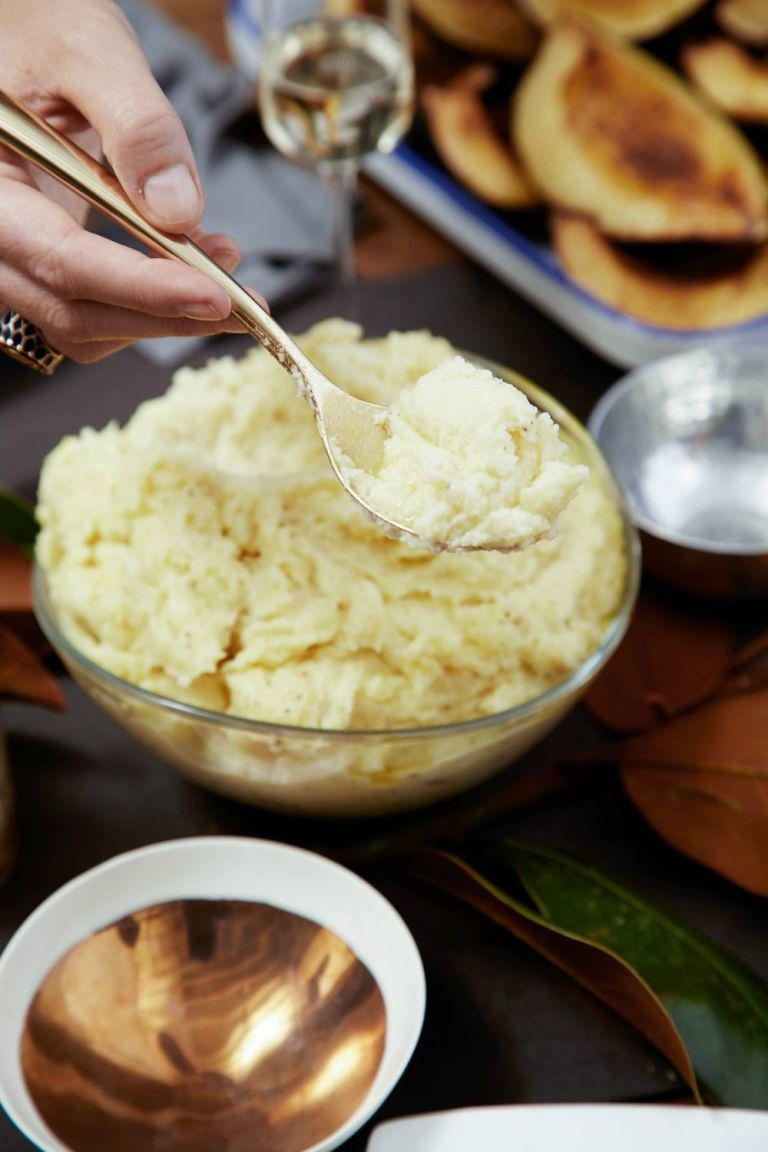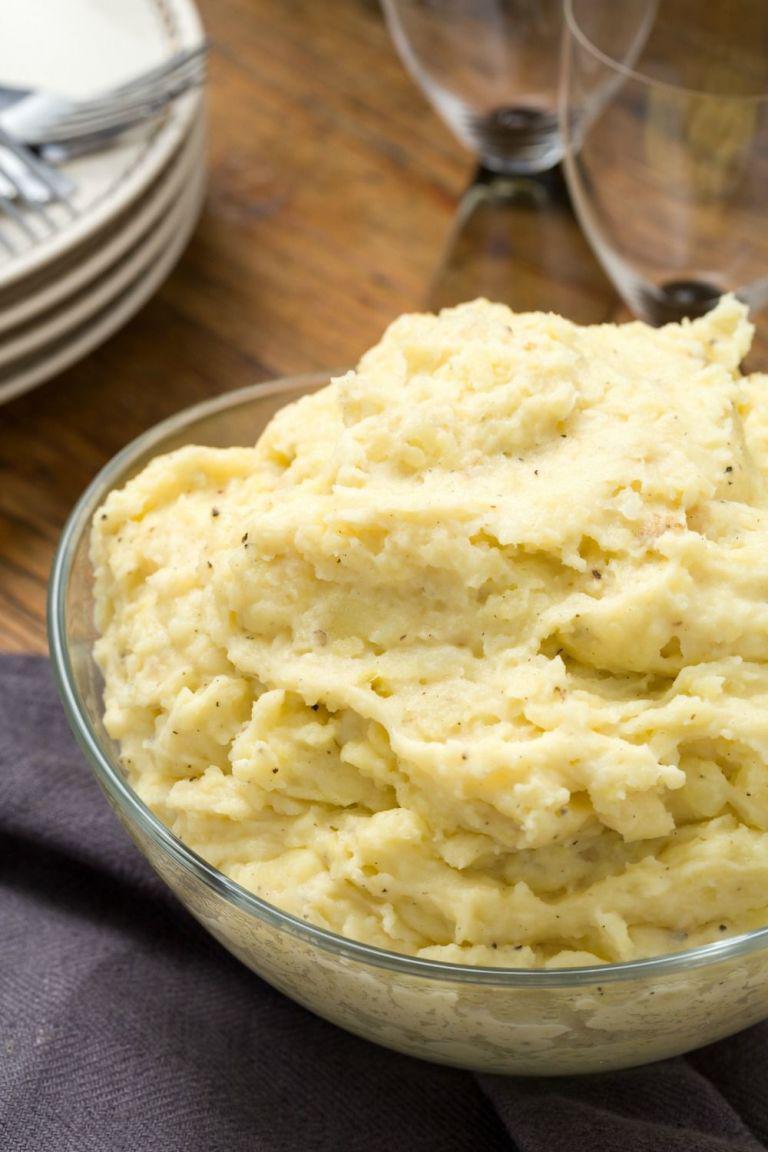The first image is the image on the left, the second image is the image on the right. Given the left and right images, does the statement "There is a silvers spoon sitting in a white bowl of food." hold true? Answer yes or no. No. The first image is the image on the left, the second image is the image on the right. For the images shown, is this caption "An eating utensil is lifted above a bowl of food." true? Answer yes or no. Yes. 